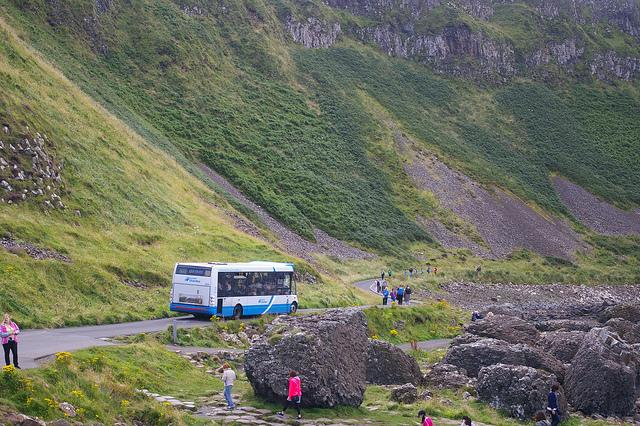What act of nature could potentially physically impede progress on the road? avalanche 